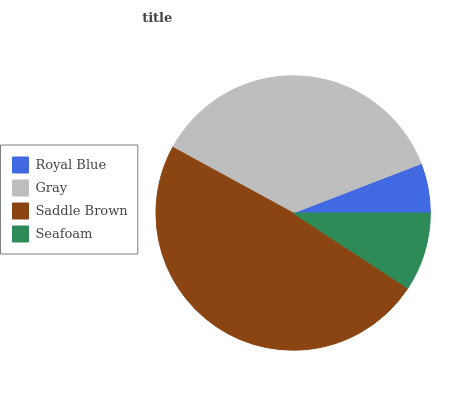Is Royal Blue the minimum?
Answer yes or no. Yes. Is Saddle Brown the maximum?
Answer yes or no. Yes. Is Gray the minimum?
Answer yes or no. No. Is Gray the maximum?
Answer yes or no. No. Is Gray greater than Royal Blue?
Answer yes or no. Yes. Is Royal Blue less than Gray?
Answer yes or no. Yes. Is Royal Blue greater than Gray?
Answer yes or no. No. Is Gray less than Royal Blue?
Answer yes or no. No. Is Gray the high median?
Answer yes or no. Yes. Is Seafoam the low median?
Answer yes or no. Yes. Is Seafoam the high median?
Answer yes or no. No. Is Royal Blue the low median?
Answer yes or no. No. 